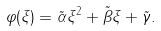<formula> <loc_0><loc_0><loc_500><loc_500>\varphi ( \xi ) = \tilde { \alpha } \xi ^ { 2 } + \tilde { \beta } \xi + \tilde { \gamma } .</formula> 